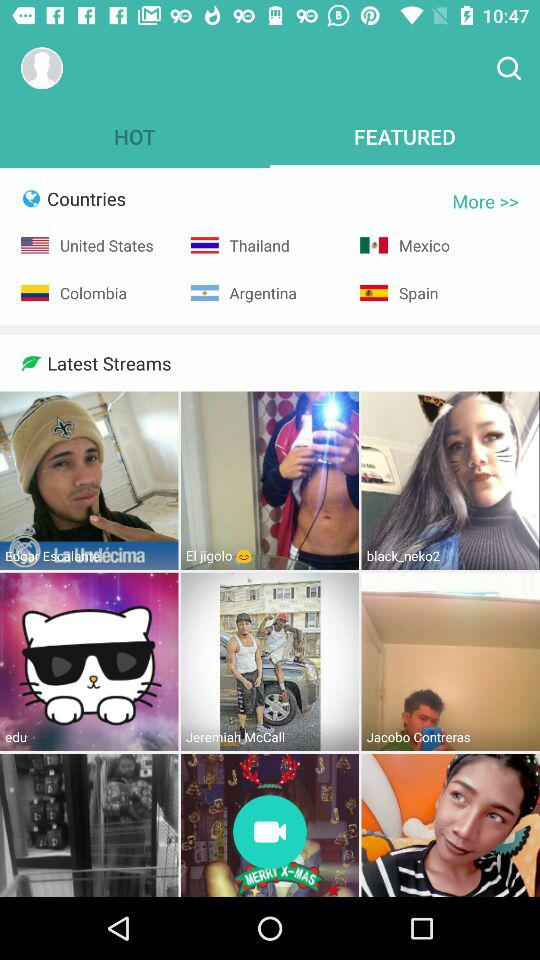Which tab am I on? You are on "FEATURED". 